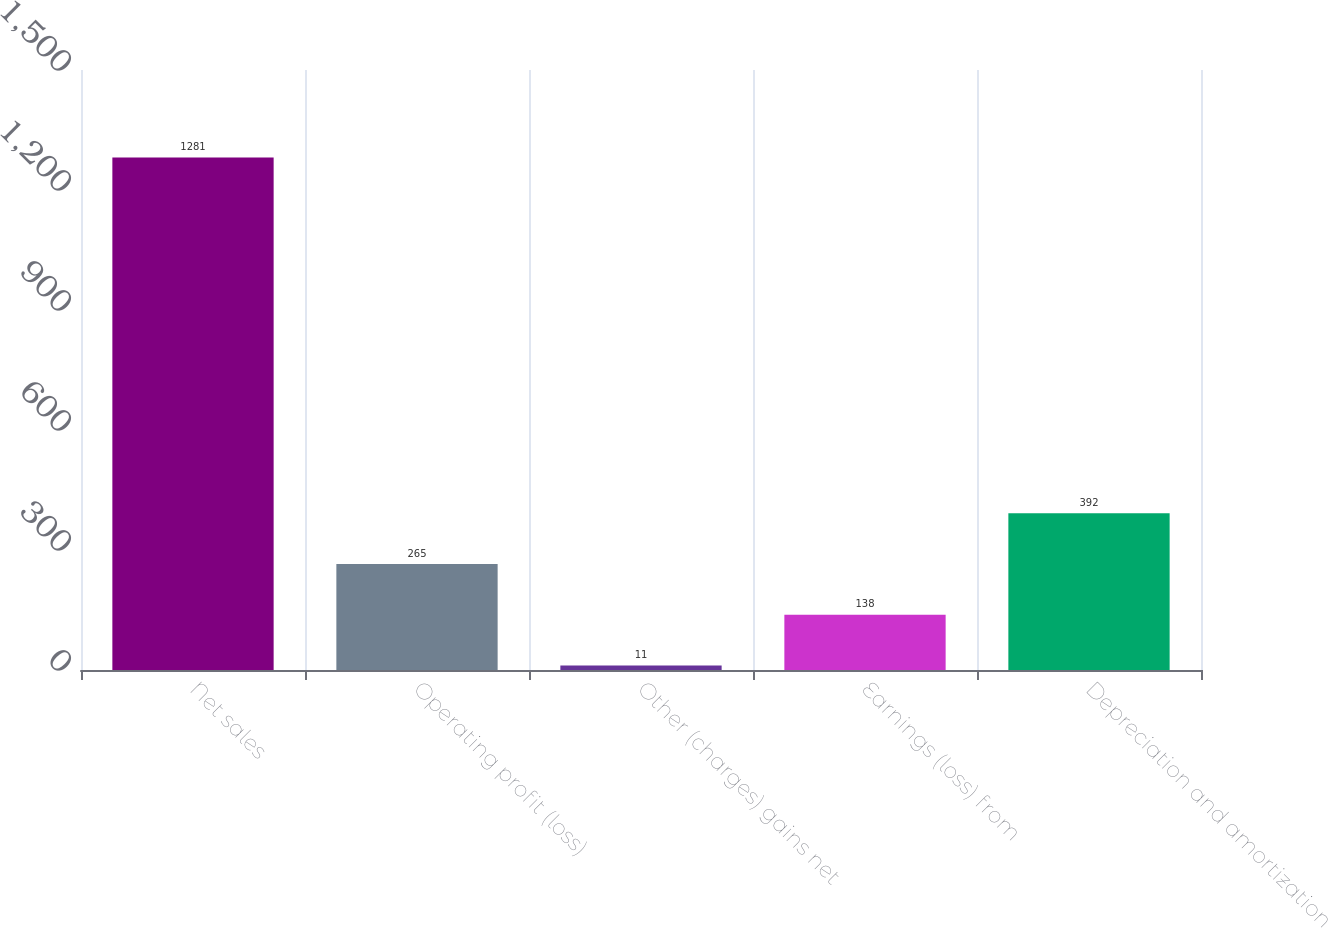Convert chart to OTSL. <chart><loc_0><loc_0><loc_500><loc_500><bar_chart><fcel>Net sales<fcel>Operating profit (loss)<fcel>Other (charges) gains net<fcel>Earnings (loss) from<fcel>Depreciation and amortization<nl><fcel>1281<fcel>265<fcel>11<fcel>138<fcel>392<nl></chart> 